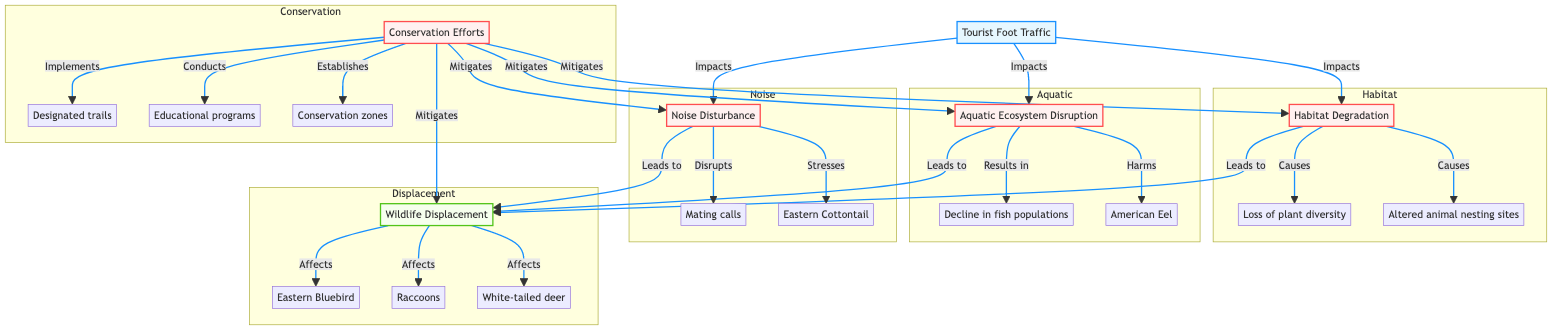What is the input node in the diagram? The input node is labeled "Tourist Foot Traffic." This can be found at the start of the diagram, indicating the initiating factor that influences the subsequent processes.
Answer: Tourist Foot Traffic How many processes are shown in the diagram? The diagram includes four processes: Habitat Degradation, Aquatic Ecosystem Disruption, Noise Disturbance, and Conservation Efforts. Each of these nodes is marked as a process type in the diagram.
Answer: Four What does "Habitat Degradation" lead to? "Habitat Degradation" leads to Wildlife Displacement. According to the arrows in the diagram, after the impact of habitat degradation is processed, it contributes to the output of wildlife displacement.
Answer: Wildlife Displacement Which animals are affected by Wildlife Displacement? The animals affected by Wildlife Displacement include Eastern Bluebird, Raccoons, and White-tailed deer. This information can be found in the output section where the affected species are listed.
Answer: Eastern Bluebird, Raccoons, White-tailed deer What is a consequence of Noise Disturbance? A consequence of Noise Disturbance is the disruption of mating calls. This information is indicated in the subgraph related to noise, highlighting the impact of increased noise on animal behavior.
Answer: Disruption of mating calls What causes "Aquatic Ecosystem Disruption"? "Aquatic Ecosystem Disruption" is caused by increased runoff, pollution from boats, and waste disposal. These causes are specifically outlined under the aquatic process in the diagram.
Answer: Increased runoff, pollution from boats, waste disposal How do Conservation Efforts impact the processes in the diagram? Conservation Efforts mitigate the effects of Habitat Degradation, Aquatic Ecosystem Disruption, Noise Disturbance, and Wildlife Displacement. The links show that these efforts have a positive impact on reducing the consequences of these negative processes.
Answer: Mitigates What are the expected results of Conservation Efforts? The expected results of Conservation Efforts are reduced habitat degradation and improved wildlife population health. This outcome is clearly stated under the conservation process in the diagram.
Answer: Reduced habitat degradation, improved wildlife population health How many outputs are shown in the diagram? The diagram shows one output, which is Wildlife Displacement. This can be identified as the final result stemming from the processes affecting habitats, ecosystems, and noise.
Answer: One 